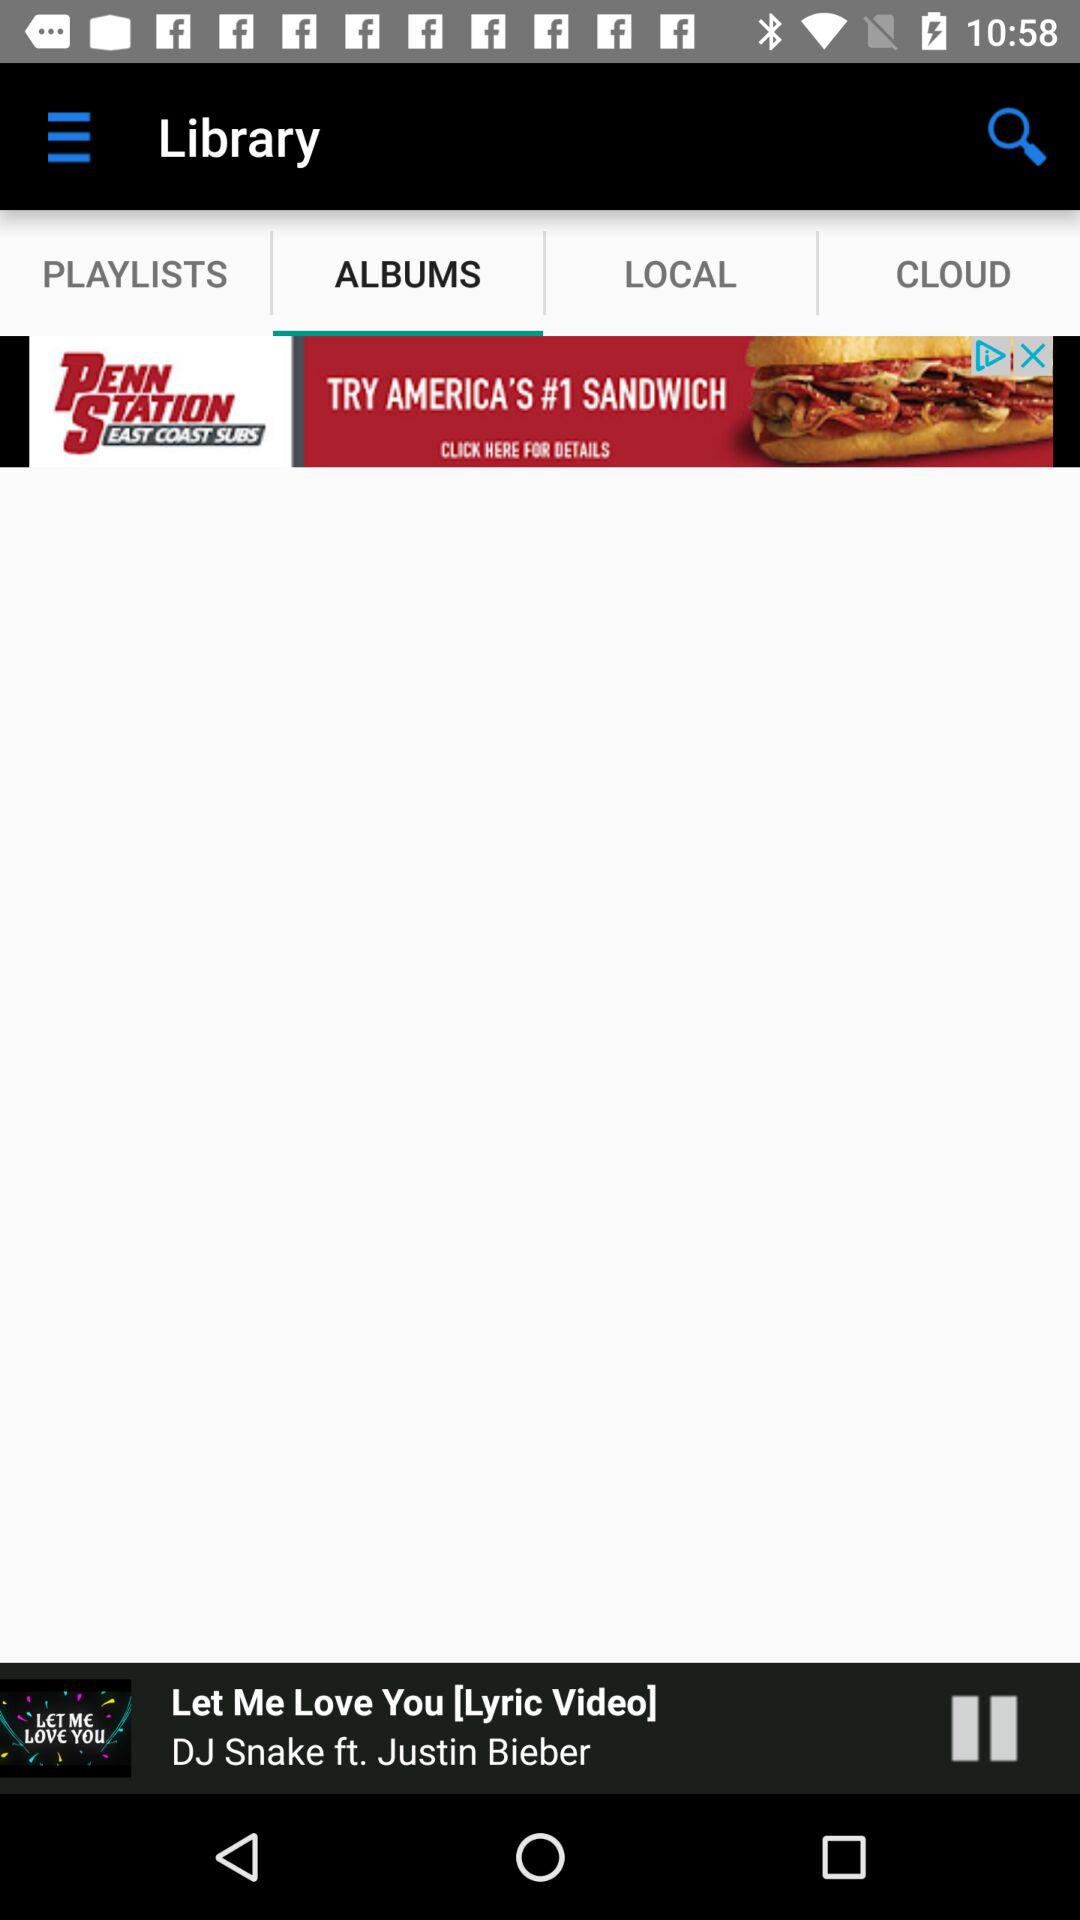Which is the selected tab? The selected tab is "ALBUMS". 